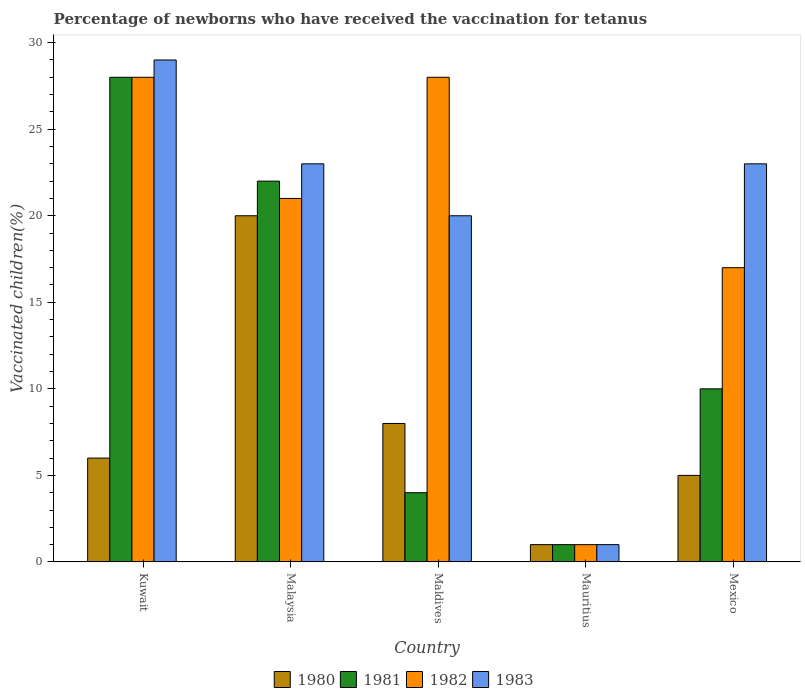How many groups of bars are there?
Provide a short and direct response. 5. Are the number of bars per tick equal to the number of legend labels?
Keep it short and to the point. Yes. How many bars are there on the 3rd tick from the left?
Your response must be concise. 4. How many bars are there on the 5th tick from the right?
Provide a short and direct response. 4. What is the label of the 1st group of bars from the left?
Ensure brevity in your answer.  Kuwait. Across all countries, what is the maximum percentage of vaccinated children in 1981?
Ensure brevity in your answer.  28. Across all countries, what is the minimum percentage of vaccinated children in 1982?
Provide a succinct answer. 1. In which country was the percentage of vaccinated children in 1981 maximum?
Offer a very short reply. Kuwait. In which country was the percentage of vaccinated children in 1980 minimum?
Offer a terse response. Mauritius. What is the total percentage of vaccinated children in 1981 in the graph?
Your response must be concise. 65. What is the difference between the percentage of vaccinated children in 1980 in Mexico and the percentage of vaccinated children in 1983 in Malaysia?
Offer a very short reply. -18. What is the difference between the percentage of vaccinated children of/in 1980 and percentage of vaccinated children of/in 1983 in Mexico?
Offer a very short reply. -18. Is the percentage of vaccinated children in 1980 in Malaysia less than that in Mauritius?
Provide a succinct answer. No. What is the difference between the highest and the lowest percentage of vaccinated children in 1980?
Keep it short and to the point. 19. Is the sum of the percentage of vaccinated children in 1980 in Kuwait and Mexico greater than the maximum percentage of vaccinated children in 1983 across all countries?
Offer a very short reply. No. What does the 4th bar from the right in Malaysia represents?
Provide a succinct answer. 1980. Are all the bars in the graph horizontal?
Your response must be concise. No. Does the graph contain any zero values?
Ensure brevity in your answer.  No. Does the graph contain grids?
Ensure brevity in your answer.  No. How are the legend labels stacked?
Ensure brevity in your answer.  Horizontal. What is the title of the graph?
Provide a short and direct response. Percentage of newborns who have received the vaccination for tetanus. Does "1978" appear as one of the legend labels in the graph?
Offer a very short reply. No. What is the label or title of the X-axis?
Ensure brevity in your answer.  Country. What is the label or title of the Y-axis?
Give a very brief answer. Vaccinated children(%). What is the Vaccinated children(%) in 1980 in Kuwait?
Offer a very short reply. 6. What is the Vaccinated children(%) in 1983 in Kuwait?
Provide a succinct answer. 29. What is the Vaccinated children(%) in 1980 in Maldives?
Your answer should be very brief. 8. What is the Vaccinated children(%) in 1982 in Maldives?
Your response must be concise. 28. What is the Vaccinated children(%) of 1980 in Mauritius?
Offer a terse response. 1. What is the Vaccinated children(%) of 1981 in Mauritius?
Provide a succinct answer. 1. What is the Vaccinated children(%) in 1982 in Mauritius?
Provide a succinct answer. 1. What is the Vaccinated children(%) in 1983 in Mauritius?
Your response must be concise. 1. What is the Vaccinated children(%) of 1982 in Mexico?
Ensure brevity in your answer.  17. What is the Vaccinated children(%) of 1983 in Mexico?
Your response must be concise. 23. Across all countries, what is the maximum Vaccinated children(%) of 1980?
Give a very brief answer. 20. Across all countries, what is the maximum Vaccinated children(%) of 1981?
Provide a short and direct response. 28. Across all countries, what is the maximum Vaccinated children(%) of 1982?
Your answer should be very brief. 28. Across all countries, what is the maximum Vaccinated children(%) of 1983?
Your answer should be compact. 29. What is the total Vaccinated children(%) in 1981 in the graph?
Your answer should be very brief. 65. What is the total Vaccinated children(%) of 1983 in the graph?
Make the answer very short. 96. What is the difference between the Vaccinated children(%) of 1980 in Kuwait and that in Malaysia?
Make the answer very short. -14. What is the difference between the Vaccinated children(%) of 1981 in Kuwait and that in Maldives?
Your answer should be very brief. 24. What is the difference between the Vaccinated children(%) in 1982 in Kuwait and that in Maldives?
Keep it short and to the point. 0. What is the difference between the Vaccinated children(%) in 1983 in Kuwait and that in Maldives?
Offer a very short reply. 9. What is the difference between the Vaccinated children(%) of 1980 in Kuwait and that in Mauritius?
Keep it short and to the point. 5. What is the difference between the Vaccinated children(%) in 1981 in Kuwait and that in Mauritius?
Your response must be concise. 27. What is the difference between the Vaccinated children(%) of 1982 in Kuwait and that in Mauritius?
Keep it short and to the point. 27. What is the difference between the Vaccinated children(%) in 1983 in Kuwait and that in Mauritius?
Make the answer very short. 28. What is the difference between the Vaccinated children(%) in 1980 in Kuwait and that in Mexico?
Make the answer very short. 1. What is the difference between the Vaccinated children(%) in 1981 in Kuwait and that in Mexico?
Give a very brief answer. 18. What is the difference between the Vaccinated children(%) in 1981 in Malaysia and that in Maldives?
Your response must be concise. 18. What is the difference between the Vaccinated children(%) of 1982 in Malaysia and that in Maldives?
Provide a short and direct response. -7. What is the difference between the Vaccinated children(%) of 1983 in Malaysia and that in Maldives?
Keep it short and to the point. 3. What is the difference between the Vaccinated children(%) of 1981 in Malaysia and that in Mauritius?
Your answer should be compact. 21. What is the difference between the Vaccinated children(%) in 1982 in Malaysia and that in Mauritius?
Make the answer very short. 20. What is the difference between the Vaccinated children(%) in 1980 in Malaysia and that in Mexico?
Make the answer very short. 15. What is the difference between the Vaccinated children(%) in 1983 in Malaysia and that in Mexico?
Give a very brief answer. 0. What is the difference between the Vaccinated children(%) in 1980 in Maldives and that in Mauritius?
Provide a succinct answer. 7. What is the difference between the Vaccinated children(%) in 1981 in Maldives and that in Mauritius?
Your response must be concise. 3. What is the difference between the Vaccinated children(%) of 1982 in Maldives and that in Mauritius?
Offer a terse response. 27. What is the difference between the Vaccinated children(%) of 1983 in Maldives and that in Mauritius?
Provide a succinct answer. 19. What is the difference between the Vaccinated children(%) in 1982 in Maldives and that in Mexico?
Provide a short and direct response. 11. What is the difference between the Vaccinated children(%) in 1982 in Mauritius and that in Mexico?
Keep it short and to the point. -16. What is the difference between the Vaccinated children(%) in 1983 in Mauritius and that in Mexico?
Your response must be concise. -22. What is the difference between the Vaccinated children(%) of 1980 in Kuwait and the Vaccinated children(%) of 1981 in Malaysia?
Give a very brief answer. -16. What is the difference between the Vaccinated children(%) in 1980 in Kuwait and the Vaccinated children(%) in 1982 in Malaysia?
Your answer should be compact. -15. What is the difference between the Vaccinated children(%) of 1980 in Kuwait and the Vaccinated children(%) of 1983 in Malaysia?
Offer a very short reply. -17. What is the difference between the Vaccinated children(%) in 1982 in Kuwait and the Vaccinated children(%) in 1983 in Malaysia?
Keep it short and to the point. 5. What is the difference between the Vaccinated children(%) in 1980 in Kuwait and the Vaccinated children(%) in 1981 in Maldives?
Offer a terse response. 2. What is the difference between the Vaccinated children(%) in 1980 in Kuwait and the Vaccinated children(%) in 1983 in Maldives?
Offer a terse response. -14. What is the difference between the Vaccinated children(%) of 1982 in Kuwait and the Vaccinated children(%) of 1983 in Maldives?
Your answer should be compact. 8. What is the difference between the Vaccinated children(%) in 1980 in Kuwait and the Vaccinated children(%) in 1981 in Mauritius?
Make the answer very short. 5. What is the difference between the Vaccinated children(%) in 1982 in Kuwait and the Vaccinated children(%) in 1983 in Mauritius?
Your answer should be very brief. 27. What is the difference between the Vaccinated children(%) of 1980 in Kuwait and the Vaccinated children(%) of 1981 in Mexico?
Provide a succinct answer. -4. What is the difference between the Vaccinated children(%) in 1980 in Kuwait and the Vaccinated children(%) in 1982 in Mexico?
Ensure brevity in your answer.  -11. What is the difference between the Vaccinated children(%) in 1980 in Kuwait and the Vaccinated children(%) in 1983 in Mexico?
Provide a short and direct response. -17. What is the difference between the Vaccinated children(%) of 1981 in Kuwait and the Vaccinated children(%) of 1983 in Mexico?
Offer a terse response. 5. What is the difference between the Vaccinated children(%) of 1980 in Malaysia and the Vaccinated children(%) of 1983 in Maldives?
Your answer should be very brief. 0. What is the difference between the Vaccinated children(%) in 1981 in Malaysia and the Vaccinated children(%) in 1982 in Maldives?
Your response must be concise. -6. What is the difference between the Vaccinated children(%) in 1981 in Malaysia and the Vaccinated children(%) in 1983 in Maldives?
Ensure brevity in your answer.  2. What is the difference between the Vaccinated children(%) in 1982 in Malaysia and the Vaccinated children(%) in 1983 in Maldives?
Ensure brevity in your answer.  1. What is the difference between the Vaccinated children(%) of 1980 in Malaysia and the Vaccinated children(%) of 1981 in Mauritius?
Provide a succinct answer. 19. What is the difference between the Vaccinated children(%) in 1980 in Malaysia and the Vaccinated children(%) in 1983 in Mauritius?
Offer a terse response. 19. What is the difference between the Vaccinated children(%) of 1981 in Malaysia and the Vaccinated children(%) of 1982 in Mauritius?
Your response must be concise. 21. What is the difference between the Vaccinated children(%) of 1982 in Malaysia and the Vaccinated children(%) of 1983 in Mauritius?
Make the answer very short. 20. What is the difference between the Vaccinated children(%) of 1980 in Malaysia and the Vaccinated children(%) of 1982 in Mexico?
Your response must be concise. 3. What is the difference between the Vaccinated children(%) of 1980 in Malaysia and the Vaccinated children(%) of 1983 in Mexico?
Ensure brevity in your answer.  -3. What is the difference between the Vaccinated children(%) of 1981 in Malaysia and the Vaccinated children(%) of 1982 in Mexico?
Keep it short and to the point. 5. What is the difference between the Vaccinated children(%) of 1981 in Malaysia and the Vaccinated children(%) of 1983 in Mexico?
Provide a succinct answer. -1. What is the difference between the Vaccinated children(%) in 1982 in Malaysia and the Vaccinated children(%) in 1983 in Mexico?
Your answer should be compact. -2. What is the difference between the Vaccinated children(%) in 1981 in Maldives and the Vaccinated children(%) in 1982 in Mauritius?
Offer a very short reply. 3. What is the difference between the Vaccinated children(%) in 1981 in Maldives and the Vaccinated children(%) in 1983 in Mauritius?
Your answer should be very brief. 3. What is the difference between the Vaccinated children(%) in 1980 in Maldives and the Vaccinated children(%) in 1983 in Mexico?
Your response must be concise. -15. What is the difference between the Vaccinated children(%) in 1981 in Maldives and the Vaccinated children(%) in 1982 in Mexico?
Provide a succinct answer. -13. What is the difference between the Vaccinated children(%) in 1981 in Maldives and the Vaccinated children(%) in 1983 in Mexico?
Keep it short and to the point. -19. What is the difference between the Vaccinated children(%) of 1982 in Maldives and the Vaccinated children(%) of 1983 in Mexico?
Offer a very short reply. 5. What is the difference between the Vaccinated children(%) in 1980 in Mauritius and the Vaccinated children(%) in 1982 in Mexico?
Offer a terse response. -16. What is the average Vaccinated children(%) of 1980 per country?
Ensure brevity in your answer.  8. What is the average Vaccinated children(%) in 1981 per country?
Your answer should be compact. 13. What is the average Vaccinated children(%) in 1982 per country?
Provide a succinct answer. 19. What is the difference between the Vaccinated children(%) in 1980 and Vaccinated children(%) in 1982 in Kuwait?
Your response must be concise. -22. What is the difference between the Vaccinated children(%) in 1981 and Vaccinated children(%) in 1982 in Kuwait?
Offer a terse response. 0. What is the difference between the Vaccinated children(%) of 1980 and Vaccinated children(%) of 1981 in Malaysia?
Keep it short and to the point. -2. What is the difference between the Vaccinated children(%) in 1980 and Vaccinated children(%) in 1983 in Malaysia?
Ensure brevity in your answer.  -3. What is the difference between the Vaccinated children(%) of 1980 and Vaccinated children(%) of 1981 in Maldives?
Provide a succinct answer. 4. What is the difference between the Vaccinated children(%) of 1981 and Vaccinated children(%) of 1983 in Maldives?
Provide a succinct answer. -16. What is the difference between the Vaccinated children(%) in 1982 and Vaccinated children(%) in 1983 in Maldives?
Give a very brief answer. 8. What is the difference between the Vaccinated children(%) in 1980 and Vaccinated children(%) in 1981 in Mauritius?
Give a very brief answer. 0. What is the difference between the Vaccinated children(%) in 1980 and Vaccinated children(%) in 1982 in Mauritius?
Your answer should be very brief. 0. What is the difference between the Vaccinated children(%) of 1981 and Vaccinated children(%) of 1982 in Mauritius?
Keep it short and to the point. 0. What is the difference between the Vaccinated children(%) of 1981 and Vaccinated children(%) of 1982 in Mexico?
Make the answer very short. -7. What is the ratio of the Vaccinated children(%) of 1980 in Kuwait to that in Malaysia?
Offer a terse response. 0.3. What is the ratio of the Vaccinated children(%) in 1981 in Kuwait to that in Malaysia?
Provide a short and direct response. 1.27. What is the ratio of the Vaccinated children(%) of 1982 in Kuwait to that in Malaysia?
Offer a very short reply. 1.33. What is the ratio of the Vaccinated children(%) in 1983 in Kuwait to that in Malaysia?
Make the answer very short. 1.26. What is the ratio of the Vaccinated children(%) in 1983 in Kuwait to that in Maldives?
Make the answer very short. 1.45. What is the ratio of the Vaccinated children(%) in 1980 in Kuwait to that in Mexico?
Offer a terse response. 1.2. What is the ratio of the Vaccinated children(%) of 1982 in Kuwait to that in Mexico?
Give a very brief answer. 1.65. What is the ratio of the Vaccinated children(%) in 1983 in Kuwait to that in Mexico?
Your response must be concise. 1.26. What is the ratio of the Vaccinated children(%) of 1980 in Malaysia to that in Maldives?
Make the answer very short. 2.5. What is the ratio of the Vaccinated children(%) of 1982 in Malaysia to that in Maldives?
Make the answer very short. 0.75. What is the ratio of the Vaccinated children(%) in 1983 in Malaysia to that in Maldives?
Ensure brevity in your answer.  1.15. What is the ratio of the Vaccinated children(%) in 1981 in Malaysia to that in Mauritius?
Your answer should be compact. 22. What is the ratio of the Vaccinated children(%) in 1982 in Malaysia to that in Mauritius?
Provide a short and direct response. 21. What is the ratio of the Vaccinated children(%) of 1981 in Malaysia to that in Mexico?
Your response must be concise. 2.2. What is the ratio of the Vaccinated children(%) in 1982 in Malaysia to that in Mexico?
Offer a terse response. 1.24. What is the ratio of the Vaccinated children(%) in 1983 in Maldives to that in Mauritius?
Offer a very short reply. 20. What is the ratio of the Vaccinated children(%) in 1982 in Maldives to that in Mexico?
Your answer should be compact. 1.65. What is the ratio of the Vaccinated children(%) of 1983 in Maldives to that in Mexico?
Give a very brief answer. 0.87. What is the ratio of the Vaccinated children(%) in 1980 in Mauritius to that in Mexico?
Make the answer very short. 0.2. What is the ratio of the Vaccinated children(%) of 1981 in Mauritius to that in Mexico?
Keep it short and to the point. 0.1. What is the ratio of the Vaccinated children(%) of 1982 in Mauritius to that in Mexico?
Provide a succinct answer. 0.06. What is the ratio of the Vaccinated children(%) of 1983 in Mauritius to that in Mexico?
Provide a short and direct response. 0.04. What is the difference between the highest and the second highest Vaccinated children(%) of 1982?
Make the answer very short. 0. What is the difference between the highest and the lowest Vaccinated children(%) of 1980?
Make the answer very short. 19. What is the difference between the highest and the lowest Vaccinated children(%) of 1981?
Your answer should be compact. 27. 